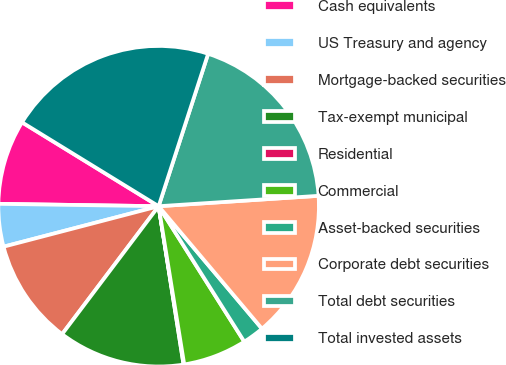Convert chart. <chart><loc_0><loc_0><loc_500><loc_500><pie_chart><fcel>Cash equivalents<fcel>US Treasury and agency<fcel>Mortgage-backed securities<fcel>Tax-exempt municipal<fcel>Residential<fcel>Commercial<fcel>Asset-backed securities<fcel>Corporate debt securities<fcel>Total debt securities<fcel>Total invested assets<nl><fcel>8.53%<fcel>4.3%<fcel>10.65%<fcel>12.77%<fcel>0.07%<fcel>6.42%<fcel>2.18%<fcel>14.88%<fcel>18.97%<fcel>21.23%<nl></chart> 